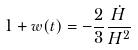<formula> <loc_0><loc_0><loc_500><loc_500>1 + w ( t ) = - \frac { 2 } { 3 } \frac { \dot { H } } { H ^ { 2 } }</formula> 